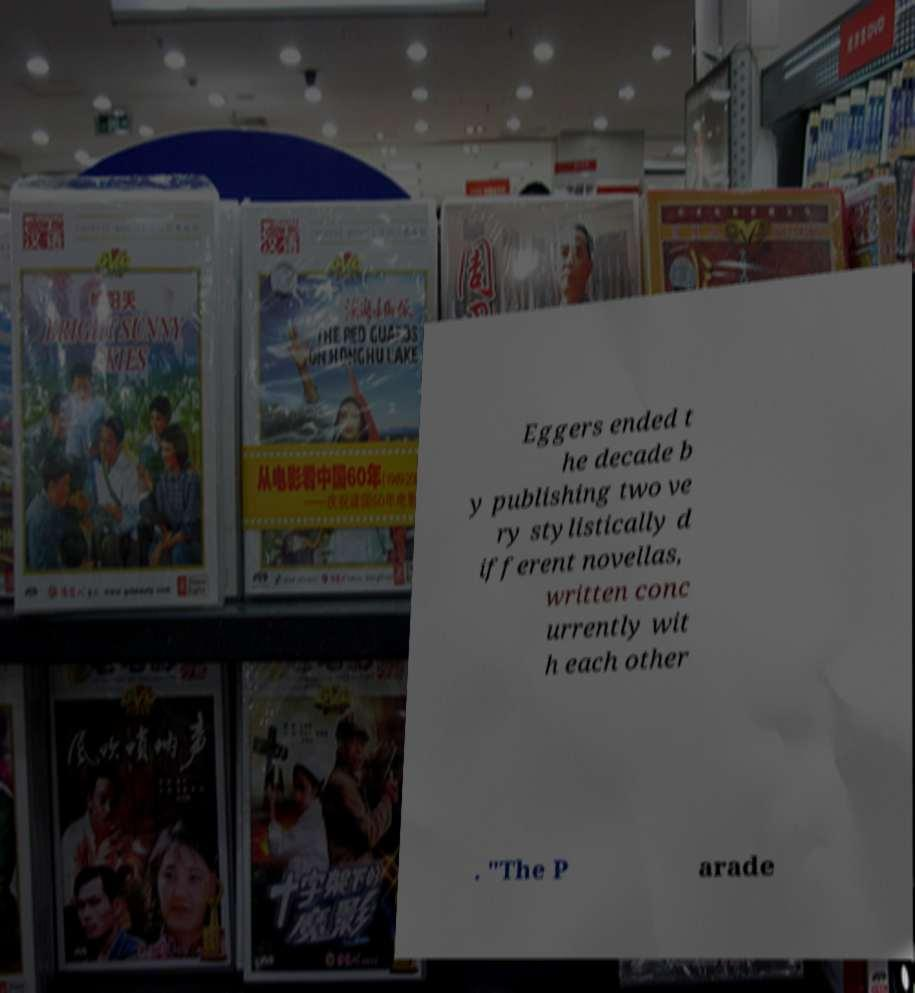There's text embedded in this image that I need extracted. Can you transcribe it verbatim? Eggers ended t he decade b y publishing two ve ry stylistically d ifferent novellas, written conc urrently wit h each other . "The P arade 